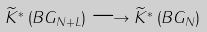Convert formula to latex. <formula><loc_0><loc_0><loc_500><loc_500>\widetilde { K } ^ { * } \left ( B G _ { N + L } \right ) \longrightarrow \widetilde { K } ^ { * } \left ( B G _ { N } \right )</formula> 